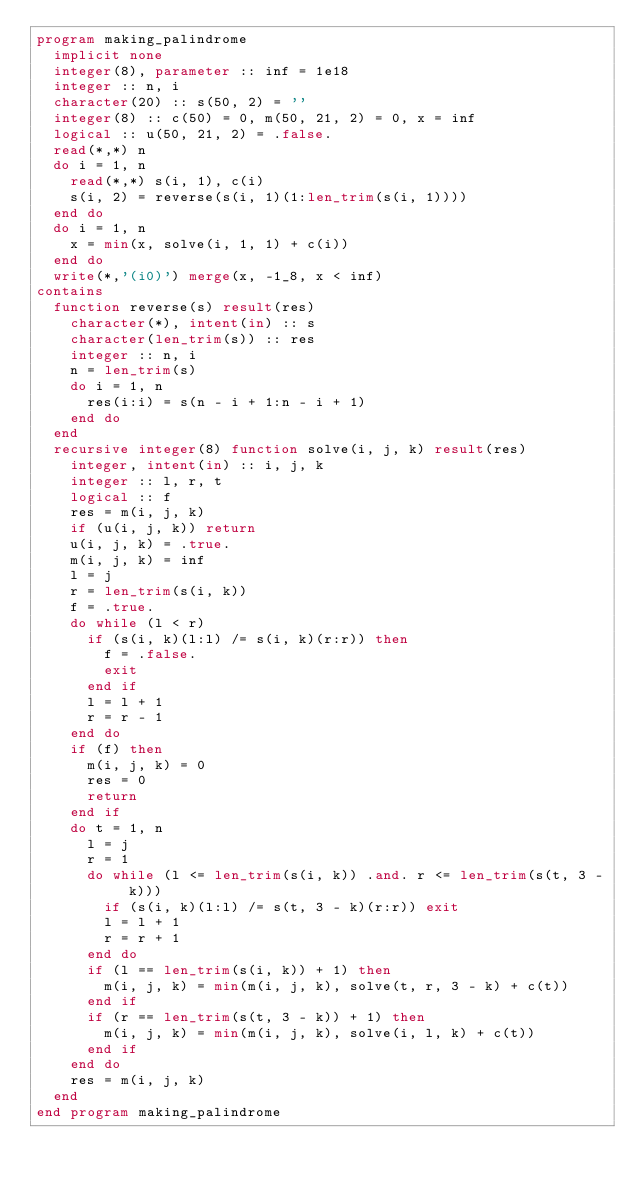<code> <loc_0><loc_0><loc_500><loc_500><_FORTRAN_>program making_palindrome
  implicit none
  integer(8), parameter :: inf = 1e18
  integer :: n, i
  character(20) :: s(50, 2) = ''
  integer(8) :: c(50) = 0, m(50, 21, 2) = 0, x = inf
  logical :: u(50, 21, 2) = .false.
  read(*,*) n
  do i = 1, n
    read(*,*) s(i, 1), c(i)
    s(i, 2) = reverse(s(i, 1)(1:len_trim(s(i, 1))))
  end do
  do i = 1, n
    x = min(x, solve(i, 1, 1) + c(i))
  end do
  write(*,'(i0)') merge(x, -1_8, x < inf)
contains
  function reverse(s) result(res)
    character(*), intent(in) :: s
    character(len_trim(s)) :: res
    integer :: n, i
    n = len_trim(s)
    do i = 1, n
      res(i:i) = s(n - i + 1:n - i + 1)
    end do
  end
  recursive integer(8) function solve(i, j, k) result(res)
    integer, intent(in) :: i, j, k
    integer :: l, r, t
    logical :: f
    res = m(i, j, k)
    if (u(i, j, k)) return
    u(i, j, k) = .true.
    m(i, j, k) = inf
    l = j
    r = len_trim(s(i, k))
    f = .true.
    do while (l < r)
      if (s(i, k)(l:l) /= s(i, k)(r:r)) then
        f = .false.
        exit
      end if
      l = l + 1
      r = r - 1
    end do
    if (f) then
      m(i, j, k) = 0
      res = 0
      return
    end if
    do t = 1, n
      l = j
      r = 1
      do while (l <= len_trim(s(i, k)) .and. r <= len_trim(s(t, 3 - k)))
        if (s(i, k)(l:l) /= s(t, 3 - k)(r:r)) exit
        l = l + 1
        r = r + 1
      end do
      if (l == len_trim(s(i, k)) + 1) then
        m(i, j, k) = min(m(i, j, k), solve(t, r, 3 - k) + c(t))
      end if
      if (r == len_trim(s(t, 3 - k)) + 1) then
        m(i, j, k) = min(m(i, j, k), solve(i, l, k) + c(t))
      end if
    end do
    res = m(i, j, k)
  end
end program making_palindrome</code> 